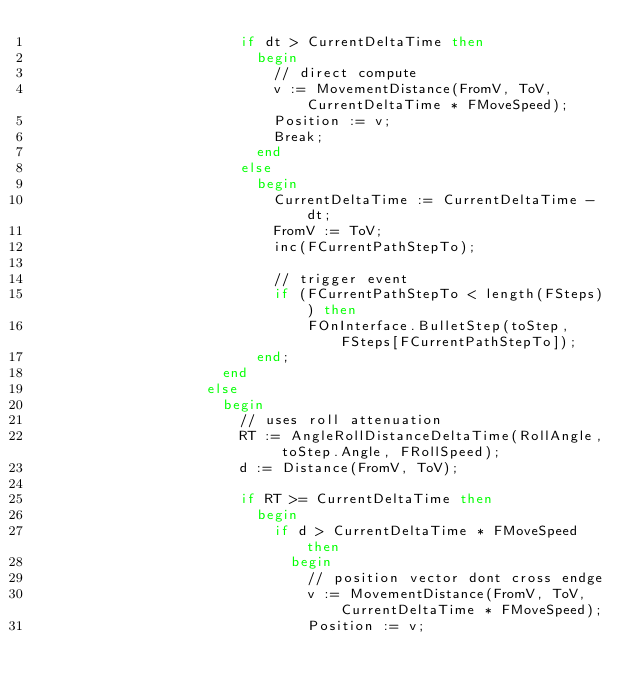Convert code to text. <code><loc_0><loc_0><loc_500><loc_500><_Pascal_>                        if dt > CurrentDeltaTime then
                          begin
                            // direct compute
                            v := MovementDistance(FromV, ToV, CurrentDeltaTime * FMoveSpeed);
                            Position := v;
                            Break;
                          end
                        else
                          begin
                            CurrentDeltaTime := CurrentDeltaTime - dt;
                            FromV := ToV;
                            inc(FCurrentPathStepTo);

                            // trigger event
                            if (FCurrentPathStepTo < length(FSteps)) then
                                FOnInterface.BulletStep(toStep, FSteps[FCurrentPathStepTo]);
                          end;
                      end
                    else
                      begin
                        // uses roll attenuation
                        RT := AngleRollDistanceDeltaTime(RollAngle, toStep.Angle, FRollSpeed);
                        d := Distance(FromV, ToV);

                        if RT >= CurrentDeltaTime then
                          begin
                            if d > CurrentDeltaTime * FMoveSpeed then
                              begin
                                // position vector dont cross endge
                                v := MovementDistance(FromV, ToV, CurrentDeltaTime * FMoveSpeed);
                                Position := v;</code> 